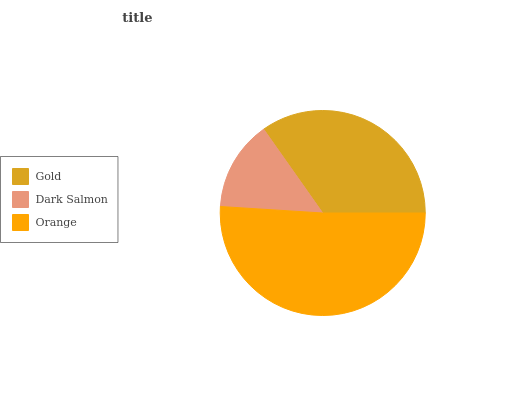Is Dark Salmon the minimum?
Answer yes or no. Yes. Is Orange the maximum?
Answer yes or no. Yes. Is Orange the minimum?
Answer yes or no. No. Is Dark Salmon the maximum?
Answer yes or no. No. Is Orange greater than Dark Salmon?
Answer yes or no. Yes. Is Dark Salmon less than Orange?
Answer yes or no. Yes. Is Dark Salmon greater than Orange?
Answer yes or no. No. Is Orange less than Dark Salmon?
Answer yes or no. No. Is Gold the high median?
Answer yes or no. Yes. Is Gold the low median?
Answer yes or no. Yes. Is Dark Salmon the high median?
Answer yes or no. No. Is Dark Salmon the low median?
Answer yes or no. No. 